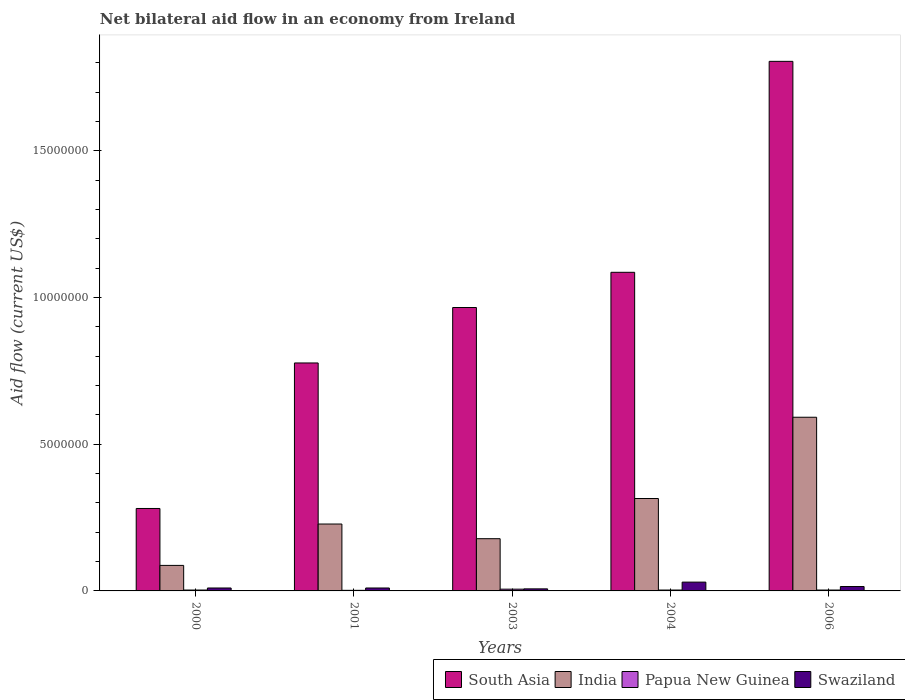How many different coloured bars are there?
Your answer should be compact. 4. How many groups of bars are there?
Provide a succinct answer. 5. Are the number of bars per tick equal to the number of legend labels?
Offer a very short reply. Yes. Are the number of bars on each tick of the X-axis equal?
Make the answer very short. Yes. How many bars are there on the 4th tick from the left?
Your answer should be very brief. 4. What is the label of the 1st group of bars from the left?
Give a very brief answer. 2000. Across all years, what is the minimum net bilateral aid flow in Papua New Guinea?
Your response must be concise. 2.00e+04. In which year was the net bilateral aid flow in Swaziland maximum?
Ensure brevity in your answer.  2004. What is the total net bilateral aid flow in Swaziland in the graph?
Make the answer very short. 7.20e+05. What is the difference between the net bilateral aid flow in South Asia in 2001 and the net bilateral aid flow in Papua New Guinea in 2004?
Make the answer very short. 7.74e+06. What is the average net bilateral aid flow in India per year?
Give a very brief answer. 2.80e+06. In the year 2006, what is the difference between the net bilateral aid flow in Papua New Guinea and net bilateral aid flow in South Asia?
Give a very brief answer. -1.80e+07. What is the ratio of the net bilateral aid flow in Swaziland in 2004 to that in 2006?
Keep it short and to the point. 2. Is the difference between the net bilateral aid flow in Papua New Guinea in 2000 and 2001 greater than the difference between the net bilateral aid flow in South Asia in 2000 and 2001?
Your answer should be compact. Yes. What is the difference between the highest and the second highest net bilateral aid flow in India?
Provide a short and direct response. 2.77e+06. In how many years, is the net bilateral aid flow in India greater than the average net bilateral aid flow in India taken over all years?
Give a very brief answer. 2. What does the 2nd bar from the left in 2000 represents?
Your response must be concise. India. What does the 2nd bar from the right in 2004 represents?
Provide a short and direct response. Papua New Guinea. Is it the case that in every year, the sum of the net bilateral aid flow in Papua New Guinea and net bilateral aid flow in South Asia is greater than the net bilateral aid flow in India?
Your answer should be compact. Yes. Are all the bars in the graph horizontal?
Your answer should be very brief. No. What is the title of the graph?
Keep it short and to the point. Net bilateral aid flow in an economy from Ireland. What is the label or title of the X-axis?
Offer a terse response. Years. What is the Aid flow (current US$) in South Asia in 2000?
Make the answer very short. 2.81e+06. What is the Aid flow (current US$) of India in 2000?
Offer a very short reply. 8.70e+05. What is the Aid flow (current US$) in Papua New Guinea in 2000?
Ensure brevity in your answer.  3.00e+04. What is the Aid flow (current US$) in Swaziland in 2000?
Provide a succinct answer. 1.00e+05. What is the Aid flow (current US$) of South Asia in 2001?
Keep it short and to the point. 7.77e+06. What is the Aid flow (current US$) of India in 2001?
Ensure brevity in your answer.  2.28e+06. What is the Aid flow (current US$) of Papua New Guinea in 2001?
Your response must be concise. 2.00e+04. What is the Aid flow (current US$) of South Asia in 2003?
Your response must be concise. 9.66e+06. What is the Aid flow (current US$) in India in 2003?
Provide a short and direct response. 1.78e+06. What is the Aid flow (current US$) in Papua New Guinea in 2003?
Give a very brief answer. 6.00e+04. What is the Aid flow (current US$) of South Asia in 2004?
Offer a very short reply. 1.09e+07. What is the Aid flow (current US$) in India in 2004?
Give a very brief answer. 3.15e+06. What is the Aid flow (current US$) of Papua New Guinea in 2004?
Offer a terse response. 3.00e+04. What is the Aid flow (current US$) of Swaziland in 2004?
Your answer should be very brief. 3.00e+05. What is the Aid flow (current US$) of South Asia in 2006?
Offer a very short reply. 1.80e+07. What is the Aid flow (current US$) in India in 2006?
Your response must be concise. 5.92e+06. Across all years, what is the maximum Aid flow (current US$) in South Asia?
Provide a succinct answer. 1.80e+07. Across all years, what is the maximum Aid flow (current US$) of India?
Keep it short and to the point. 5.92e+06. Across all years, what is the maximum Aid flow (current US$) of Papua New Guinea?
Provide a succinct answer. 6.00e+04. Across all years, what is the minimum Aid flow (current US$) of South Asia?
Provide a short and direct response. 2.81e+06. Across all years, what is the minimum Aid flow (current US$) of India?
Make the answer very short. 8.70e+05. Across all years, what is the minimum Aid flow (current US$) in Swaziland?
Your answer should be compact. 7.00e+04. What is the total Aid flow (current US$) of South Asia in the graph?
Offer a very short reply. 4.92e+07. What is the total Aid flow (current US$) in India in the graph?
Give a very brief answer. 1.40e+07. What is the total Aid flow (current US$) of Swaziland in the graph?
Provide a succinct answer. 7.20e+05. What is the difference between the Aid flow (current US$) in South Asia in 2000 and that in 2001?
Your answer should be very brief. -4.96e+06. What is the difference between the Aid flow (current US$) in India in 2000 and that in 2001?
Ensure brevity in your answer.  -1.41e+06. What is the difference between the Aid flow (current US$) in Papua New Guinea in 2000 and that in 2001?
Keep it short and to the point. 10000. What is the difference between the Aid flow (current US$) in Swaziland in 2000 and that in 2001?
Your response must be concise. 0. What is the difference between the Aid flow (current US$) in South Asia in 2000 and that in 2003?
Offer a very short reply. -6.85e+06. What is the difference between the Aid flow (current US$) of India in 2000 and that in 2003?
Your response must be concise. -9.10e+05. What is the difference between the Aid flow (current US$) in Swaziland in 2000 and that in 2003?
Provide a short and direct response. 3.00e+04. What is the difference between the Aid flow (current US$) in South Asia in 2000 and that in 2004?
Make the answer very short. -8.05e+06. What is the difference between the Aid flow (current US$) in India in 2000 and that in 2004?
Offer a very short reply. -2.28e+06. What is the difference between the Aid flow (current US$) in Papua New Guinea in 2000 and that in 2004?
Give a very brief answer. 0. What is the difference between the Aid flow (current US$) in South Asia in 2000 and that in 2006?
Ensure brevity in your answer.  -1.52e+07. What is the difference between the Aid flow (current US$) of India in 2000 and that in 2006?
Your answer should be very brief. -5.05e+06. What is the difference between the Aid flow (current US$) in South Asia in 2001 and that in 2003?
Give a very brief answer. -1.89e+06. What is the difference between the Aid flow (current US$) in South Asia in 2001 and that in 2004?
Your answer should be compact. -3.09e+06. What is the difference between the Aid flow (current US$) of India in 2001 and that in 2004?
Keep it short and to the point. -8.70e+05. What is the difference between the Aid flow (current US$) of South Asia in 2001 and that in 2006?
Provide a succinct answer. -1.03e+07. What is the difference between the Aid flow (current US$) of India in 2001 and that in 2006?
Your answer should be compact. -3.64e+06. What is the difference between the Aid flow (current US$) in Swaziland in 2001 and that in 2006?
Offer a terse response. -5.00e+04. What is the difference between the Aid flow (current US$) in South Asia in 2003 and that in 2004?
Offer a very short reply. -1.20e+06. What is the difference between the Aid flow (current US$) in India in 2003 and that in 2004?
Keep it short and to the point. -1.37e+06. What is the difference between the Aid flow (current US$) of Papua New Guinea in 2003 and that in 2004?
Provide a succinct answer. 3.00e+04. What is the difference between the Aid flow (current US$) of Swaziland in 2003 and that in 2004?
Provide a succinct answer. -2.30e+05. What is the difference between the Aid flow (current US$) of South Asia in 2003 and that in 2006?
Keep it short and to the point. -8.39e+06. What is the difference between the Aid flow (current US$) of India in 2003 and that in 2006?
Offer a terse response. -4.14e+06. What is the difference between the Aid flow (current US$) of Papua New Guinea in 2003 and that in 2006?
Offer a very short reply. 3.00e+04. What is the difference between the Aid flow (current US$) in Swaziland in 2003 and that in 2006?
Keep it short and to the point. -8.00e+04. What is the difference between the Aid flow (current US$) of South Asia in 2004 and that in 2006?
Your answer should be very brief. -7.19e+06. What is the difference between the Aid flow (current US$) in India in 2004 and that in 2006?
Ensure brevity in your answer.  -2.77e+06. What is the difference between the Aid flow (current US$) of Papua New Guinea in 2004 and that in 2006?
Provide a succinct answer. 0. What is the difference between the Aid flow (current US$) of South Asia in 2000 and the Aid flow (current US$) of India in 2001?
Make the answer very short. 5.30e+05. What is the difference between the Aid flow (current US$) in South Asia in 2000 and the Aid flow (current US$) in Papua New Guinea in 2001?
Your response must be concise. 2.79e+06. What is the difference between the Aid flow (current US$) in South Asia in 2000 and the Aid flow (current US$) in Swaziland in 2001?
Offer a very short reply. 2.71e+06. What is the difference between the Aid flow (current US$) in India in 2000 and the Aid flow (current US$) in Papua New Guinea in 2001?
Give a very brief answer. 8.50e+05. What is the difference between the Aid flow (current US$) in India in 2000 and the Aid flow (current US$) in Swaziland in 2001?
Your answer should be compact. 7.70e+05. What is the difference between the Aid flow (current US$) of Papua New Guinea in 2000 and the Aid flow (current US$) of Swaziland in 2001?
Offer a very short reply. -7.00e+04. What is the difference between the Aid flow (current US$) of South Asia in 2000 and the Aid flow (current US$) of India in 2003?
Offer a terse response. 1.03e+06. What is the difference between the Aid flow (current US$) in South Asia in 2000 and the Aid flow (current US$) in Papua New Guinea in 2003?
Give a very brief answer. 2.75e+06. What is the difference between the Aid flow (current US$) of South Asia in 2000 and the Aid flow (current US$) of Swaziland in 2003?
Keep it short and to the point. 2.74e+06. What is the difference between the Aid flow (current US$) in India in 2000 and the Aid flow (current US$) in Papua New Guinea in 2003?
Ensure brevity in your answer.  8.10e+05. What is the difference between the Aid flow (current US$) of Papua New Guinea in 2000 and the Aid flow (current US$) of Swaziland in 2003?
Make the answer very short. -4.00e+04. What is the difference between the Aid flow (current US$) in South Asia in 2000 and the Aid flow (current US$) in Papua New Guinea in 2004?
Offer a terse response. 2.78e+06. What is the difference between the Aid flow (current US$) in South Asia in 2000 and the Aid flow (current US$) in Swaziland in 2004?
Keep it short and to the point. 2.51e+06. What is the difference between the Aid flow (current US$) in India in 2000 and the Aid flow (current US$) in Papua New Guinea in 2004?
Provide a short and direct response. 8.40e+05. What is the difference between the Aid flow (current US$) in India in 2000 and the Aid flow (current US$) in Swaziland in 2004?
Your answer should be compact. 5.70e+05. What is the difference between the Aid flow (current US$) of Papua New Guinea in 2000 and the Aid flow (current US$) of Swaziland in 2004?
Offer a terse response. -2.70e+05. What is the difference between the Aid flow (current US$) of South Asia in 2000 and the Aid flow (current US$) of India in 2006?
Keep it short and to the point. -3.11e+06. What is the difference between the Aid flow (current US$) of South Asia in 2000 and the Aid flow (current US$) of Papua New Guinea in 2006?
Your response must be concise. 2.78e+06. What is the difference between the Aid flow (current US$) in South Asia in 2000 and the Aid flow (current US$) in Swaziland in 2006?
Ensure brevity in your answer.  2.66e+06. What is the difference between the Aid flow (current US$) of India in 2000 and the Aid flow (current US$) of Papua New Guinea in 2006?
Make the answer very short. 8.40e+05. What is the difference between the Aid flow (current US$) in India in 2000 and the Aid flow (current US$) in Swaziland in 2006?
Your answer should be very brief. 7.20e+05. What is the difference between the Aid flow (current US$) in Papua New Guinea in 2000 and the Aid flow (current US$) in Swaziland in 2006?
Provide a short and direct response. -1.20e+05. What is the difference between the Aid flow (current US$) in South Asia in 2001 and the Aid flow (current US$) in India in 2003?
Make the answer very short. 5.99e+06. What is the difference between the Aid flow (current US$) in South Asia in 2001 and the Aid flow (current US$) in Papua New Guinea in 2003?
Your answer should be compact. 7.71e+06. What is the difference between the Aid flow (current US$) of South Asia in 2001 and the Aid flow (current US$) of Swaziland in 2003?
Offer a terse response. 7.70e+06. What is the difference between the Aid flow (current US$) of India in 2001 and the Aid flow (current US$) of Papua New Guinea in 2003?
Provide a succinct answer. 2.22e+06. What is the difference between the Aid flow (current US$) in India in 2001 and the Aid flow (current US$) in Swaziland in 2003?
Provide a succinct answer. 2.21e+06. What is the difference between the Aid flow (current US$) of Papua New Guinea in 2001 and the Aid flow (current US$) of Swaziland in 2003?
Keep it short and to the point. -5.00e+04. What is the difference between the Aid flow (current US$) of South Asia in 2001 and the Aid flow (current US$) of India in 2004?
Your answer should be very brief. 4.62e+06. What is the difference between the Aid flow (current US$) in South Asia in 2001 and the Aid flow (current US$) in Papua New Guinea in 2004?
Offer a terse response. 7.74e+06. What is the difference between the Aid flow (current US$) in South Asia in 2001 and the Aid flow (current US$) in Swaziland in 2004?
Offer a terse response. 7.47e+06. What is the difference between the Aid flow (current US$) in India in 2001 and the Aid flow (current US$) in Papua New Guinea in 2004?
Provide a short and direct response. 2.25e+06. What is the difference between the Aid flow (current US$) in India in 2001 and the Aid flow (current US$) in Swaziland in 2004?
Offer a very short reply. 1.98e+06. What is the difference between the Aid flow (current US$) in Papua New Guinea in 2001 and the Aid flow (current US$) in Swaziland in 2004?
Your answer should be compact. -2.80e+05. What is the difference between the Aid flow (current US$) of South Asia in 2001 and the Aid flow (current US$) of India in 2006?
Ensure brevity in your answer.  1.85e+06. What is the difference between the Aid flow (current US$) in South Asia in 2001 and the Aid flow (current US$) in Papua New Guinea in 2006?
Provide a succinct answer. 7.74e+06. What is the difference between the Aid flow (current US$) in South Asia in 2001 and the Aid flow (current US$) in Swaziland in 2006?
Your answer should be compact. 7.62e+06. What is the difference between the Aid flow (current US$) of India in 2001 and the Aid flow (current US$) of Papua New Guinea in 2006?
Provide a succinct answer. 2.25e+06. What is the difference between the Aid flow (current US$) of India in 2001 and the Aid flow (current US$) of Swaziland in 2006?
Provide a short and direct response. 2.13e+06. What is the difference between the Aid flow (current US$) in South Asia in 2003 and the Aid flow (current US$) in India in 2004?
Provide a short and direct response. 6.51e+06. What is the difference between the Aid flow (current US$) of South Asia in 2003 and the Aid flow (current US$) of Papua New Guinea in 2004?
Offer a terse response. 9.63e+06. What is the difference between the Aid flow (current US$) in South Asia in 2003 and the Aid flow (current US$) in Swaziland in 2004?
Your answer should be very brief. 9.36e+06. What is the difference between the Aid flow (current US$) in India in 2003 and the Aid flow (current US$) in Papua New Guinea in 2004?
Ensure brevity in your answer.  1.75e+06. What is the difference between the Aid flow (current US$) of India in 2003 and the Aid flow (current US$) of Swaziland in 2004?
Provide a short and direct response. 1.48e+06. What is the difference between the Aid flow (current US$) of Papua New Guinea in 2003 and the Aid flow (current US$) of Swaziland in 2004?
Provide a short and direct response. -2.40e+05. What is the difference between the Aid flow (current US$) in South Asia in 2003 and the Aid flow (current US$) in India in 2006?
Offer a terse response. 3.74e+06. What is the difference between the Aid flow (current US$) of South Asia in 2003 and the Aid flow (current US$) of Papua New Guinea in 2006?
Your answer should be compact. 9.63e+06. What is the difference between the Aid flow (current US$) of South Asia in 2003 and the Aid flow (current US$) of Swaziland in 2006?
Provide a succinct answer. 9.51e+06. What is the difference between the Aid flow (current US$) of India in 2003 and the Aid flow (current US$) of Papua New Guinea in 2006?
Keep it short and to the point. 1.75e+06. What is the difference between the Aid flow (current US$) of India in 2003 and the Aid flow (current US$) of Swaziland in 2006?
Your response must be concise. 1.63e+06. What is the difference between the Aid flow (current US$) in Papua New Guinea in 2003 and the Aid flow (current US$) in Swaziland in 2006?
Provide a short and direct response. -9.00e+04. What is the difference between the Aid flow (current US$) in South Asia in 2004 and the Aid flow (current US$) in India in 2006?
Make the answer very short. 4.94e+06. What is the difference between the Aid flow (current US$) of South Asia in 2004 and the Aid flow (current US$) of Papua New Guinea in 2006?
Your answer should be very brief. 1.08e+07. What is the difference between the Aid flow (current US$) in South Asia in 2004 and the Aid flow (current US$) in Swaziland in 2006?
Your answer should be very brief. 1.07e+07. What is the difference between the Aid flow (current US$) in India in 2004 and the Aid flow (current US$) in Papua New Guinea in 2006?
Your answer should be very brief. 3.12e+06. What is the average Aid flow (current US$) in South Asia per year?
Your answer should be compact. 9.83e+06. What is the average Aid flow (current US$) of India per year?
Provide a short and direct response. 2.80e+06. What is the average Aid flow (current US$) of Papua New Guinea per year?
Provide a short and direct response. 3.40e+04. What is the average Aid flow (current US$) of Swaziland per year?
Give a very brief answer. 1.44e+05. In the year 2000, what is the difference between the Aid flow (current US$) of South Asia and Aid flow (current US$) of India?
Your response must be concise. 1.94e+06. In the year 2000, what is the difference between the Aid flow (current US$) of South Asia and Aid flow (current US$) of Papua New Guinea?
Offer a terse response. 2.78e+06. In the year 2000, what is the difference between the Aid flow (current US$) in South Asia and Aid flow (current US$) in Swaziland?
Make the answer very short. 2.71e+06. In the year 2000, what is the difference between the Aid flow (current US$) in India and Aid flow (current US$) in Papua New Guinea?
Provide a succinct answer. 8.40e+05. In the year 2000, what is the difference between the Aid flow (current US$) of India and Aid flow (current US$) of Swaziland?
Give a very brief answer. 7.70e+05. In the year 2000, what is the difference between the Aid flow (current US$) in Papua New Guinea and Aid flow (current US$) in Swaziland?
Offer a very short reply. -7.00e+04. In the year 2001, what is the difference between the Aid flow (current US$) of South Asia and Aid flow (current US$) of India?
Your answer should be very brief. 5.49e+06. In the year 2001, what is the difference between the Aid flow (current US$) of South Asia and Aid flow (current US$) of Papua New Guinea?
Provide a succinct answer. 7.75e+06. In the year 2001, what is the difference between the Aid flow (current US$) in South Asia and Aid flow (current US$) in Swaziland?
Provide a succinct answer. 7.67e+06. In the year 2001, what is the difference between the Aid flow (current US$) of India and Aid flow (current US$) of Papua New Guinea?
Offer a very short reply. 2.26e+06. In the year 2001, what is the difference between the Aid flow (current US$) in India and Aid flow (current US$) in Swaziland?
Offer a very short reply. 2.18e+06. In the year 2003, what is the difference between the Aid flow (current US$) of South Asia and Aid flow (current US$) of India?
Provide a short and direct response. 7.88e+06. In the year 2003, what is the difference between the Aid flow (current US$) in South Asia and Aid flow (current US$) in Papua New Guinea?
Offer a very short reply. 9.60e+06. In the year 2003, what is the difference between the Aid flow (current US$) of South Asia and Aid flow (current US$) of Swaziland?
Offer a terse response. 9.59e+06. In the year 2003, what is the difference between the Aid flow (current US$) of India and Aid flow (current US$) of Papua New Guinea?
Offer a terse response. 1.72e+06. In the year 2003, what is the difference between the Aid flow (current US$) in India and Aid flow (current US$) in Swaziland?
Your response must be concise. 1.71e+06. In the year 2003, what is the difference between the Aid flow (current US$) in Papua New Guinea and Aid flow (current US$) in Swaziland?
Ensure brevity in your answer.  -10000. In the year 2004, what is the difference between the Aid flow (current US$) in South Asia and Aid flow (current US$) in India?
Your response must be concise. 7.71e+06. In the year 2004, what is the difference between the Aid flow (current US$) in South Asia and Aid flow (current US$) in Papua New Guinea?
Your answer should be compact. 1.08e+07. In the year 2004, what is the difference between the Aid flow (current US$) in South Asia and Aid flow (current US$) in Swaziland?
Keep it short and to the point. 1.06e+07. In the year 2004, what is the difference between the Aid flow (current US$) of India and Aid flow (current US$) of Papua New Guinea?
Ensure brevity in your answer.  3.12e+06. In the year 2004, what is the difference between the Aid flow (current US$) in India and Aid flow (current US$) in Swaziland?
Your answer should be very brief. 2.85e+06. In the year 2004, what is the difference between the Aid flow (current US$) in Papua New Guinea and Aid flow (current US$) in Swaziland?
Keep it short and to the point. -2.70e+05. In the year 2006, what is the difference between the Aid flow (current US$) of South Asia and Aid flow (current US$) of India?
Your response must be concise. 1.21e+07. In the year 2006, what is the difference between the Aid flow (current US$) of South Asia and Aid flow (current US$) of Papua New Guinea?
Your answer should be compact. 1.80e+07. In the year 2006, what is the difference between the Aid flow (current US$) of South Asia and Aid flow (current US$) of Swaziland?
Make the answer very short. 1.79e+07. In the year 2006, what is the difference between the Aid flow (current US$) of India and Aid flow (current US$) of Papua New Guinea?
Offer a very short reply. 5.89e+06. In the year 2006, what is the difference between the Aid flow (current US$) in India and Aid flow (current US$) in Swaziland?
Give a very brief answer. 5.77e+06. What is the ratio of the Aid flow (current US$) in South Asia in 2000 to that in 2001?
Offer a terse response. 0.36. What is the ratio of the Aid flow (current US$) of India in 2000 to that in 2001?
Provide a short and direct response. 0.38. What is the ratio of the Aid flow (current US$) in Papua New Guinea in 2000 to that in 2001?
Offer a terse response. 1.5. What is the ratio of the Aid flow (current US$) in South Asia in 2000 to that in 2003?
Ensure brevity in your answer.  0.29. What is the ratio of the Aid flow (current US$) in India in 2000 to that in 2003?
Your answer should be very brief. 0.49. What is the ratio of the Aid flow (current US$) in Swaziland in 2000 to that in 2003?
Your answer should be compact. 1.43. What is the ratio of the Aid flow (current US$) of South Asia in 2000 to that in 2004?
Provide a short and direct response. 0.26. What is the ratio of the Aid flow (current US$) of India in 2000 to that in 2004?
Offer a terse response. 0.28. What is the ratio of the Aid flow (current US$) in Papua New Guinea in 2000 to that in 2004?
Provide a succinct answer. 1. What is the ratio of the Aid flow (current US$) in Swaziland in 2000 to that in 2004?
Provide a succinct answer. 0.33. What is the ratio of the Aid flow (current US$) in South Asia in 2000 to that in 2006?
Offer a terse response. 0.16. What is the ratio of the Aid flow (current US$) in India in 2000 to that in 2006?
Your answer should be compact. 0.15. What is the ratio of the Aid flow (current US$) in Papua New Guinea in 2000 to that in 2006?
Your response must be concise. 1. What is the ratio of the Aid flow (current US$) in Swaziland in 2000 to that in 2006?
Your answer should be very brief. 0.67. What is the ratio of the Aid flow (current US$) of South Asia in 2001 to that in 2003?
Give a very brief answer. 0.8. What is the ratio of the Aid flow (current US$) in India in 2001 to that in 2003?
Offer a very short reply. 1.28. What is the ratio of the Aid flow (current US$) in Swaziland in 2001 to that in 2003?
Offer a very short reply. 1.43. What is the ratio of the Aid flow (current US$) in South Asia in 2001 to that in 2004?
Provide a short and direct response. 0.72. What is the ratio of the Aid flow (current US$) in India in 2001 to that in 2004?
Your answer should be compact. 0.72. What is the ratio of the Aid flow (current US$) in Papua New Guinea in 2001 to that in 2004?
Make the answer very short. 0.67. What is the ratio of the Aid flow (current US$) in South Asia in 2001 to that in 2006?
Your answer should be compact. 0.43. What is the ratio of the Aid flow (current US$) in India in 2001 to that in 2006?
Keep it short and to the point. 0.39. What is the ratio of the Aid flow (current US$) in Papua New Guinea in 2001 to that in 2006?
Ensure brevity in your answer.  0.67. What is the ratio of the Aid flow (current US$) of South Asia in 2003 to that in 2004?
Make the answer very short. 0.89. What is the ratio of the Aid flow (current US$) in India in 2003 to that in 2004?
Make the answer very short. 0.57. What is the ratio of the Aid flow (current US$) in Papua New Guinea in 2003 to that in 2004?
Provide a short and direct response. 2. What is the ratio of the Aid flow (current US$) in Swaziland in 2003 to that in 2004?
Ensure brevity in your answer.  0.23. What is the ratio of the Aid flow (current US$) in South Asia in 2003 to that in 2006?
Provide a short and direct response. 0.54. What is the ratio of the Aid flow (current US$) of India in 2003 to that in 2006?
Your answer should be very brief. 0.3. What is the ratio of the Aid flow (current US$) of Papua New Guinea in 2003 to that in 2006?
Make the answer very short. 2. What is the ratio of the Aid flow (current US$) in Swaziland in 2003 to that in 2006?
Offer a terse response. 0.47. What is the ratio of the Aid flow (current US$) of South Asia in 2004 to that in 2006?
Give a very brief answer. 0.6. What is the ratio of the Aid flow (current US$) of India in 2004 to that in 2006?
Offer a terse response. 0.53. What is the difference between the highest and the second highest Aid flow (current US$) of South Asia?
Your answer should be very brief. 7.19e+06. What is the difference between the highest and the second highest Aid flow (current US$) of India?
Provide a succinct answer. 2.77e+06. What is the difference between the highest and the second highest Aid flow (current US$) in Papua New Guinea?
Your answer should be very brief. 3.00e+04. What is the difference between the highest and the second highest Aid flow (current US$) of Swaziland?
Your response must be concise. 1.50e+05. What is the difference between the highest and the lowest Aid flow (current US$) of South Asia?
Your answer should be very brief. 1.52e+07. What is the difference between the highest and the lowest Aid flow (current US$) in India?
Your answer should be compact. 5.05e+06. What is the difference between the highest and the lowest Aid flow (current US$) in Papua New Guinea?
Offer a very short reply. 4.00e+04. What is the difference between the highest and the lowest Aid flow (current US$) in Swaziland?
Provide a succinct answer. 2.30e+05. 